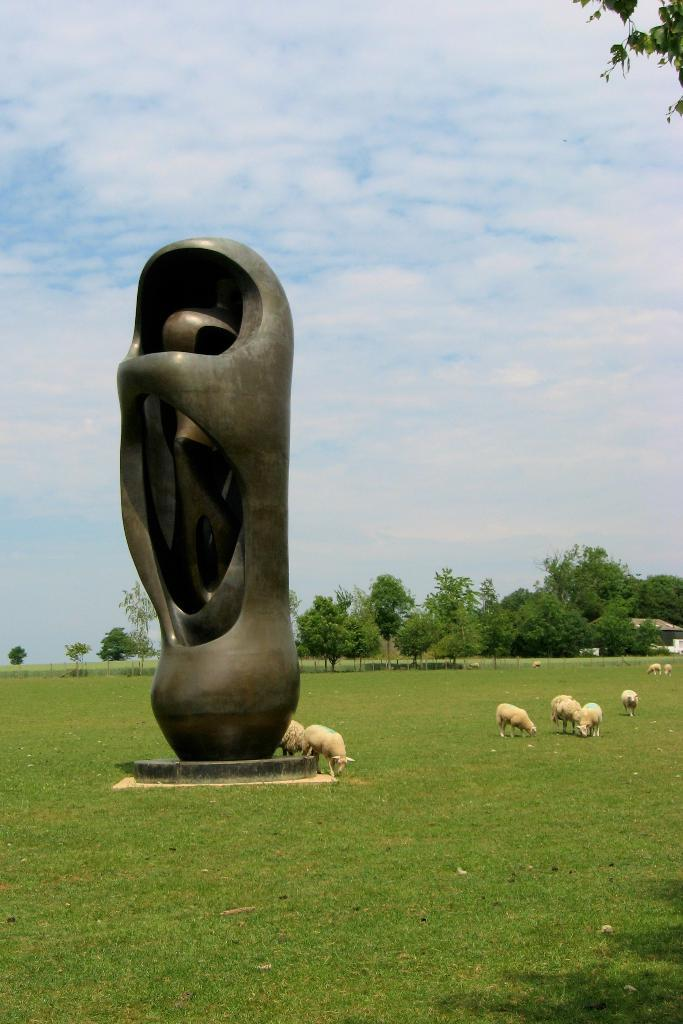What can be found in the garden in the image? There is a statue in the garden. What else is present around the statue? There are animals around the statue. What can be seen in the background of the image? There are trees in the background of the image. What type of cherry is being used as a prop for the statue in the image? There is no cherry present in the image, and the statue is not using any props. 